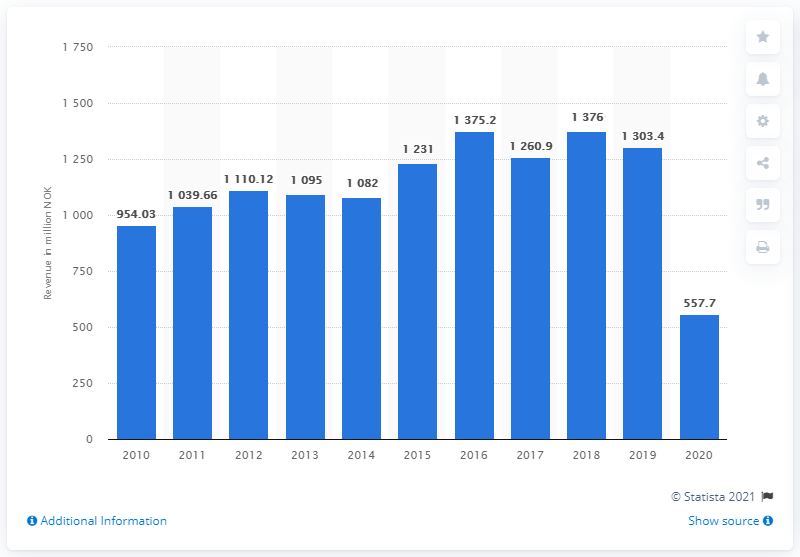Mention a couple of crucial points in this snapshot. In 2020, the gross box office revenue in Norway was 557.7 million US dollars. In 2019, the box office revenue in Norwegian cinemas was NOK 1303.4 million. 